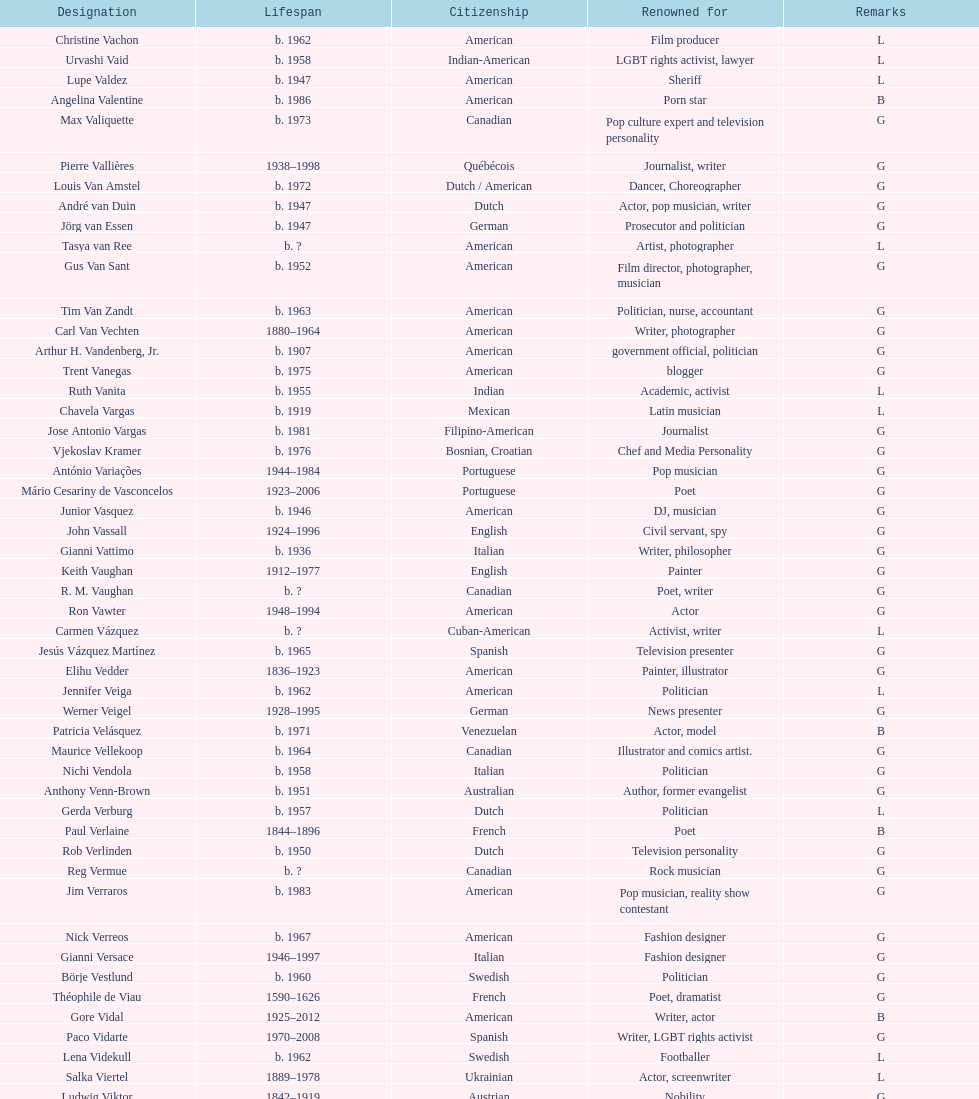Which is the previous name from lupe valdez Urvashi Vaid. 